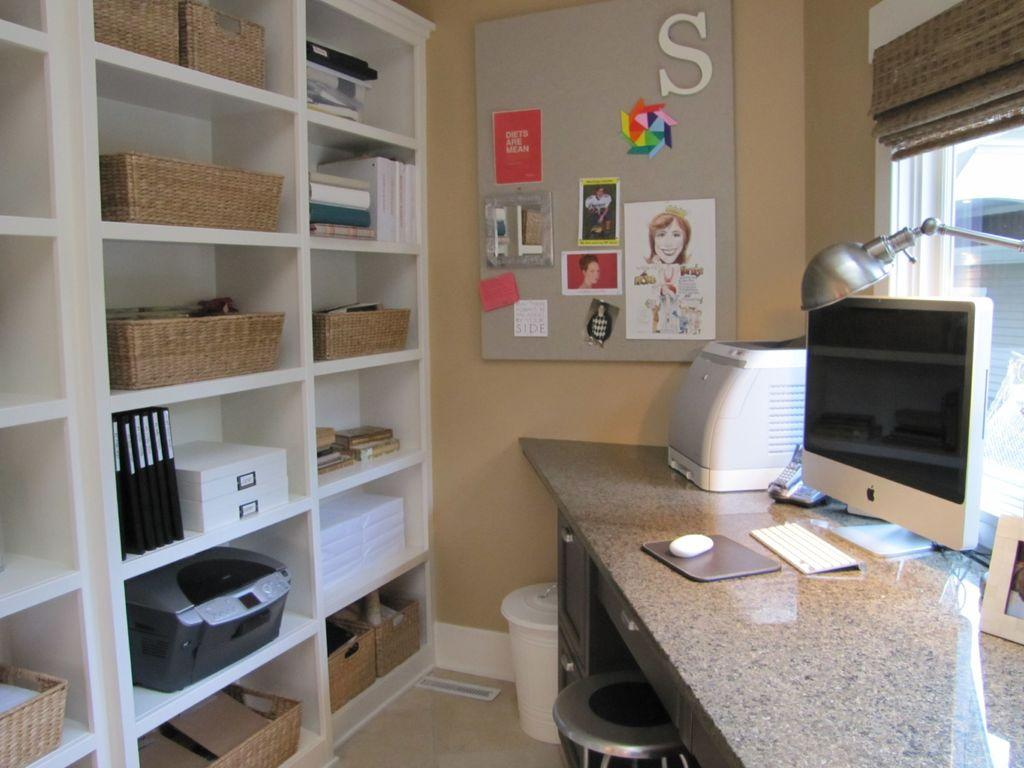<image>
Provide a brief description of the given image. A bulletin board with a large white S on it hangs in a tidy office. 